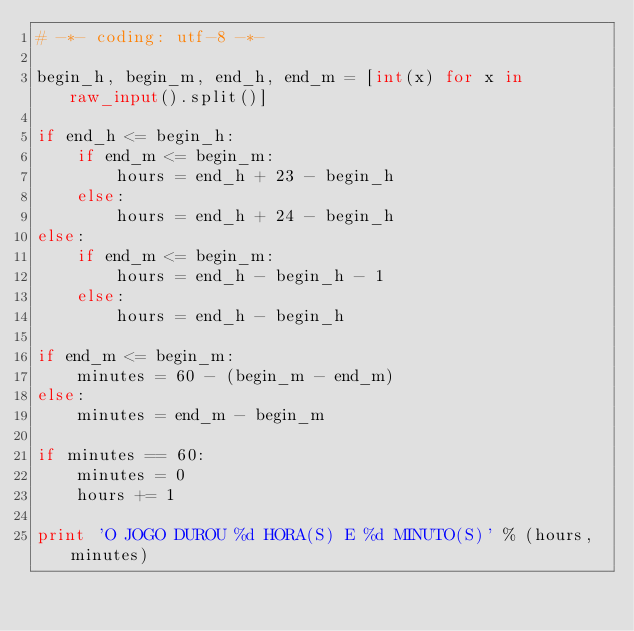Convert code to text. <code><loc_0><loc_0><loc_500><loc_500><_Python_># -*- coding: utf-8 -*-

begin_h, begin_m, end_h, end_m = [int(x) for x in raw_input().split()]

if end_h <= begin_h:
    if end_m <= begin_m:
        hours = end_h + 23 - begin_h
    else:
        hours = end_h + 24 - begin_h
else:
    if end_m <= begin_m:
        hours = end_h - begin_h - 1
    else:
        hours = end_h - begin_h

if end_m <= begin_m:
    minutes = 60 - (begin_m - end_m)
else:
    minutes = end_m - begin_m

if minutes == 60:
    minutes = 0
    hours += 1

print 'O JOGO DUROU %d HORA(S) E %d MINUTO(S)' % (hours, minutes)
</code> 